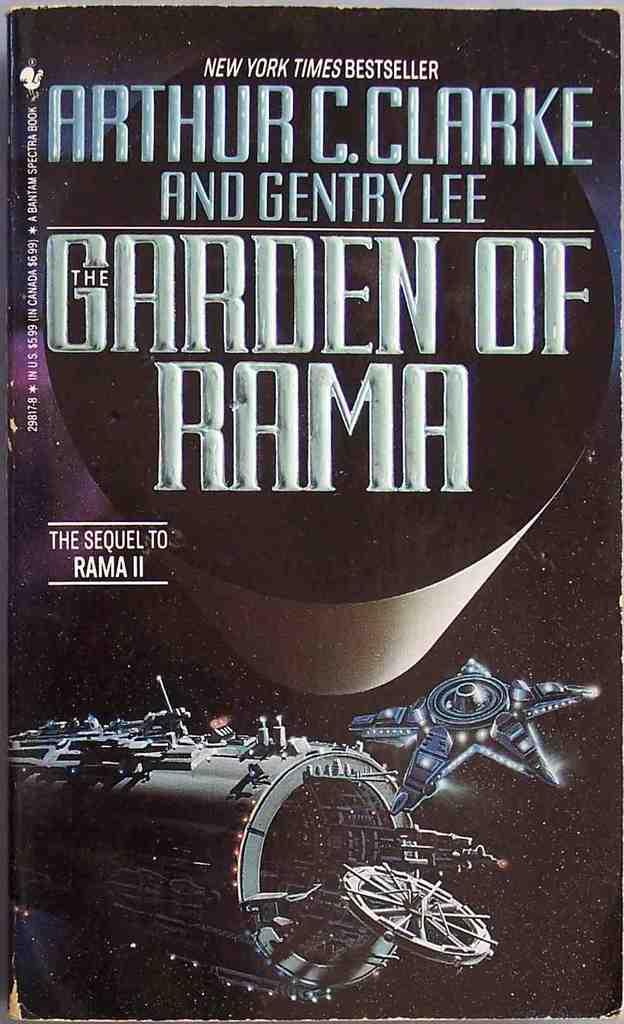Who is the authors of this book?
Offer a terse response. Arthur c. clarke. 